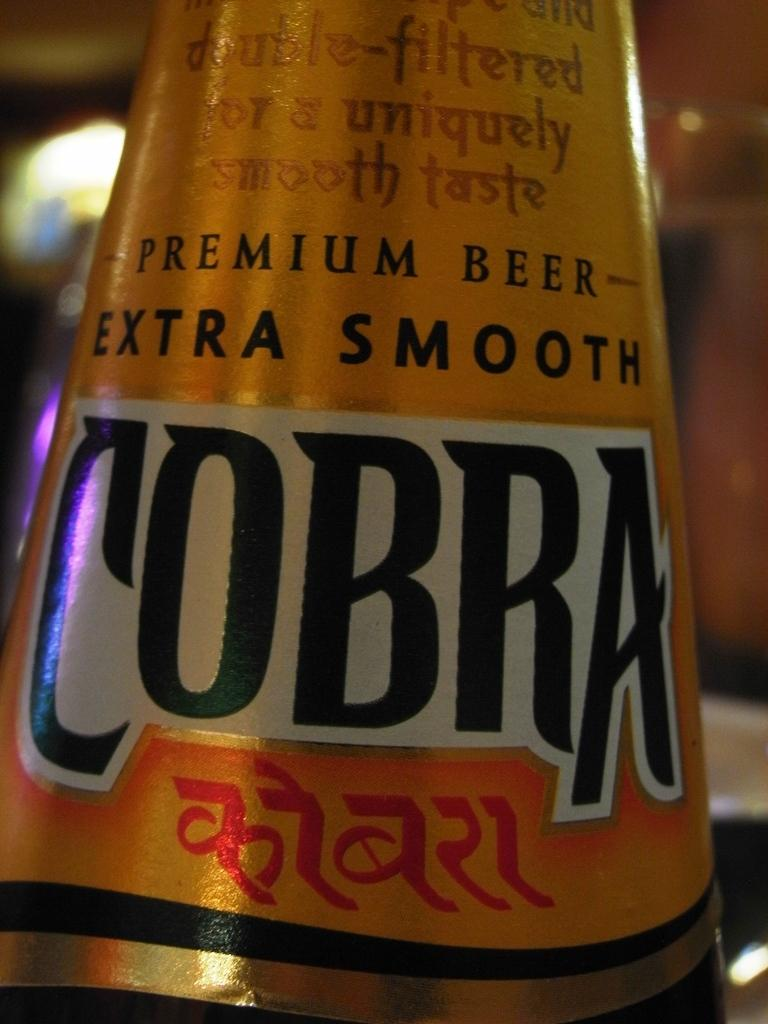<image>
Write a terse but informative summary of the picture. a closeup of the label for Cobra premium beer extra smooth 